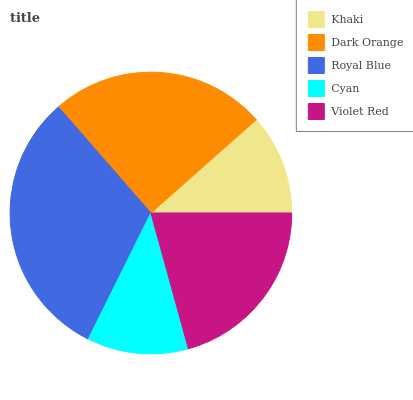Is Khaki the minimum?
Answer yes or no. Yes. Is Royal Blue the maximum?
Answer yes or no. Yes. Is Dark Orange the minimum?
Answer yes or no. No. Is Dark Orange the maximum?
Answer yes or no. No. Is Dark Orange greater than Khaki?
Answer yes or no. Yes. Is Khaki less than Dark Orange?
Answer yes or no. Yes. Is Khaki greater than Dark Orange?
Answer yes or no. No. Is Dark Orange less than Khaki?
Answer yes or no. No. Is Violet Red the high median?
Answer yes or no. Yes. Is Violet Red the low median?
Answer yes or no. Yes. Is Dark Orange the high median?
Answer yes or no. No. Is Dark Orange the low median?
Answer yes or no. No. 